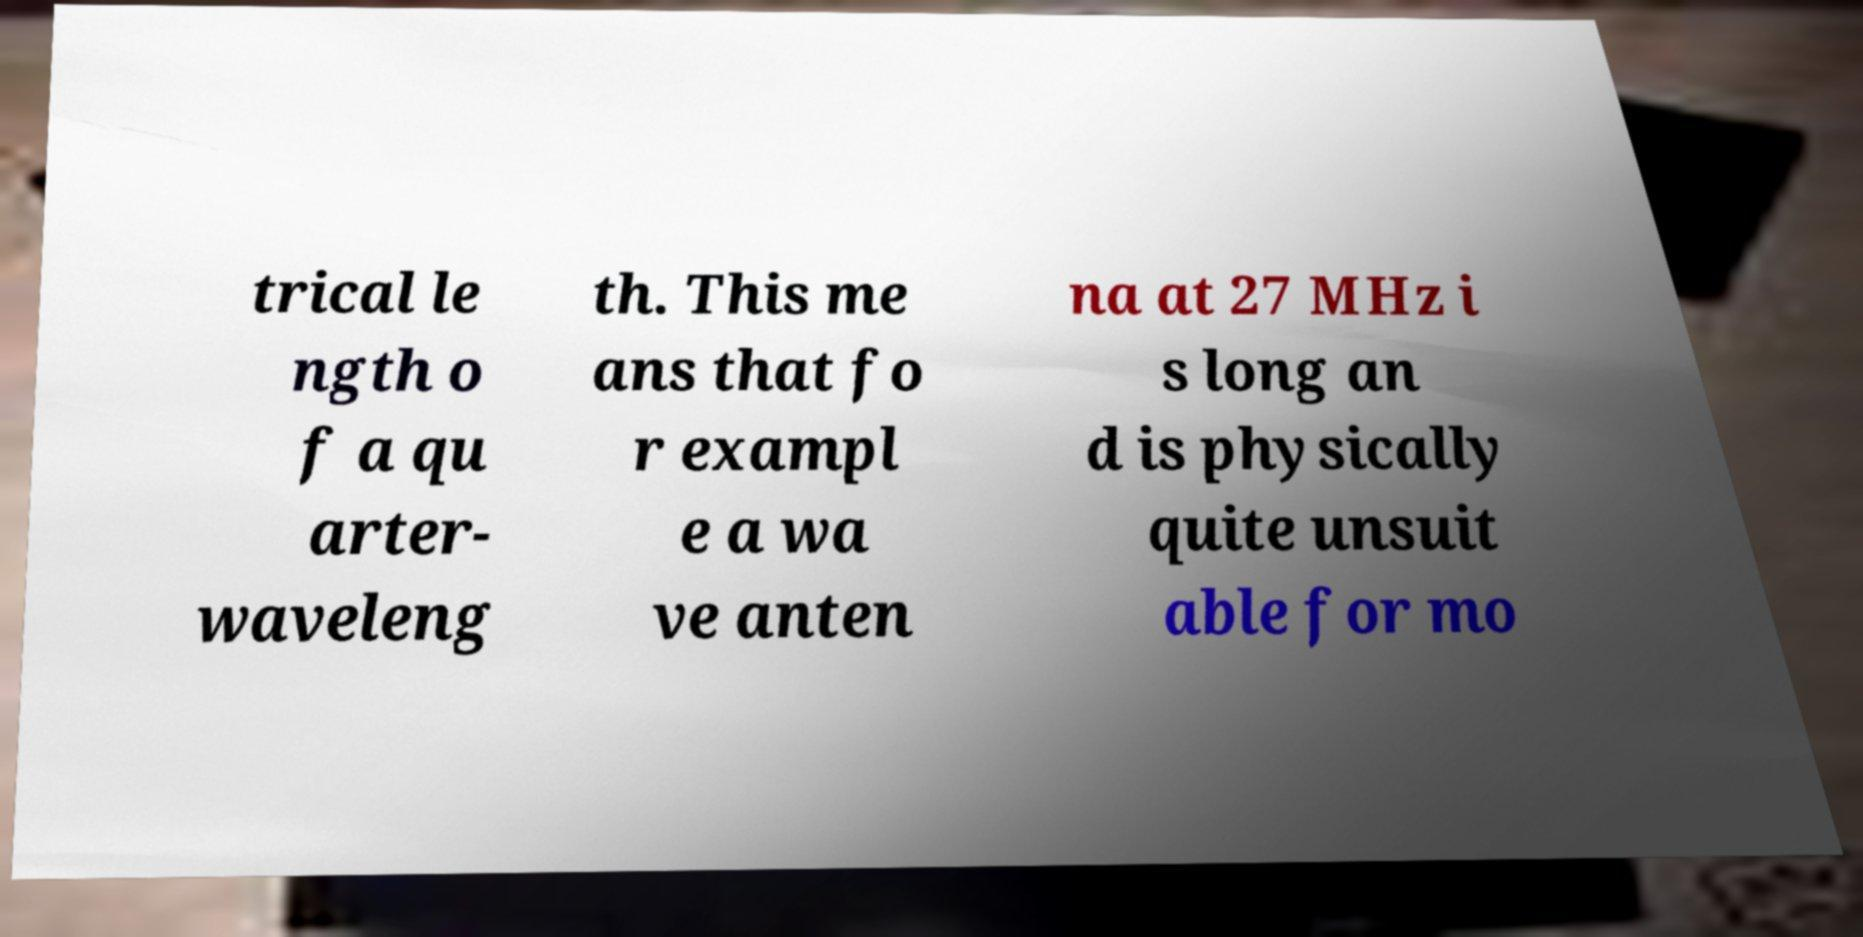There's text embedded in this image that I need extracted. Can you transcribe it verbatim? trical le ngth o f a qu arter- waveleng th. This me ans that fo r exampl e a wa ve anten na at 27 MHz i s long an d is physically quite unsuit able for mo 